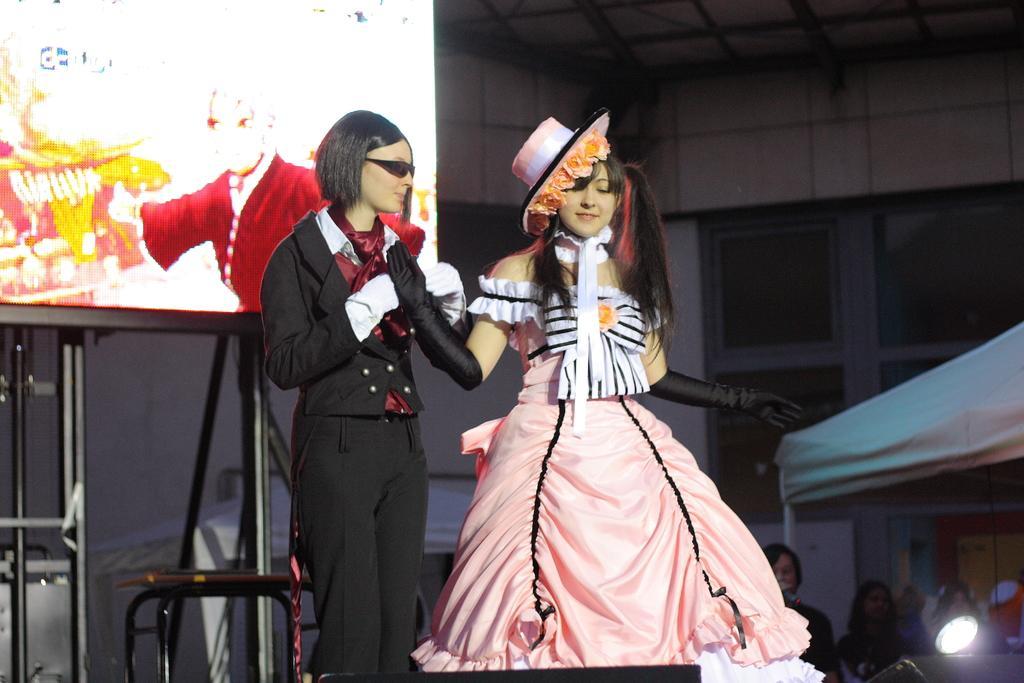Can you describe this image briefly? In this picture we can see few people, in the top left hand corner we can see a screen and few metal rods, on the right side of the image we can find a tent and a light. 